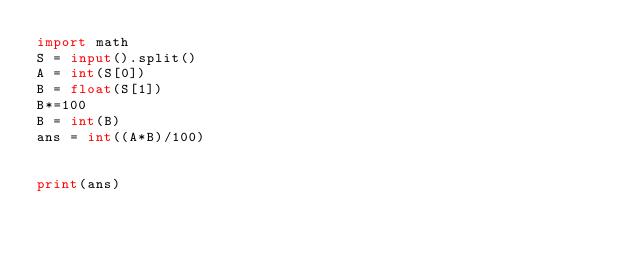<code> <loc_0><loc_0><loc_500><loc_500><_Python_>import math
S = input().split()
A = int(S[0])
B = float(S[1])
B*=100
B = int(B)
ans = int((A*B)/100)


print(ans)

</code> 